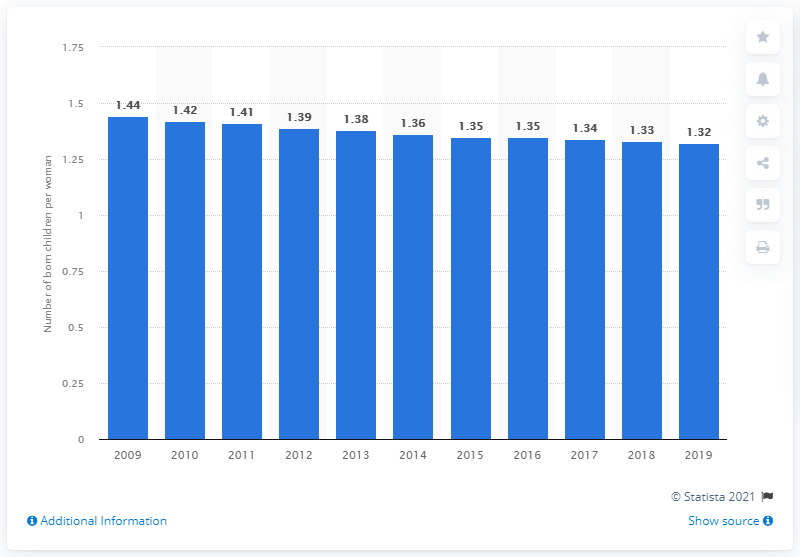Highlight a few significant elements in this photo. The fertility rate in Cyprus in 2019 was 1.32. 